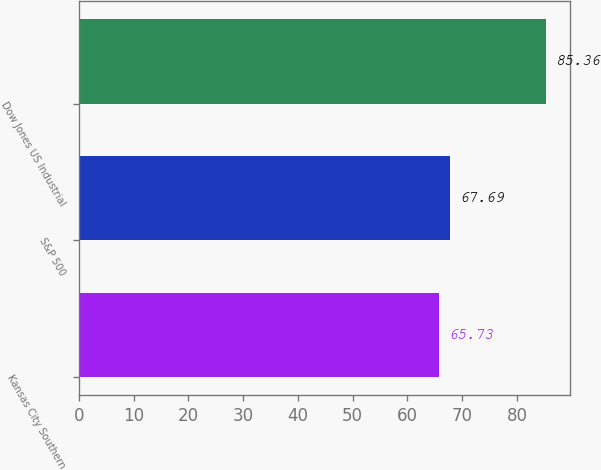Convert chart. <chart><loc_0><loc_0><loc_500><loc_500><bar_chart><fcel>Kansas City Southern<fcel>S&P 500<fcel>Dow Jones US Industrial<nl><fcel>65.73<fcel>67.69<fcel>85.36<nl></chart> 